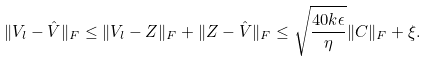Convert formula to latex. <formula><loc_0><loc_0><loc_500><loc_500>\| V _ { l } - \hat { V } \| _ { F } \leq \| V _ { l } - Z \| _ { F } + \| Z - \hat { V } \| _ { F } \leq \sqrt { \frac { 4 0 k \epsilon } { \eta } } \| C \| _ { F } + \xi .</formula> 